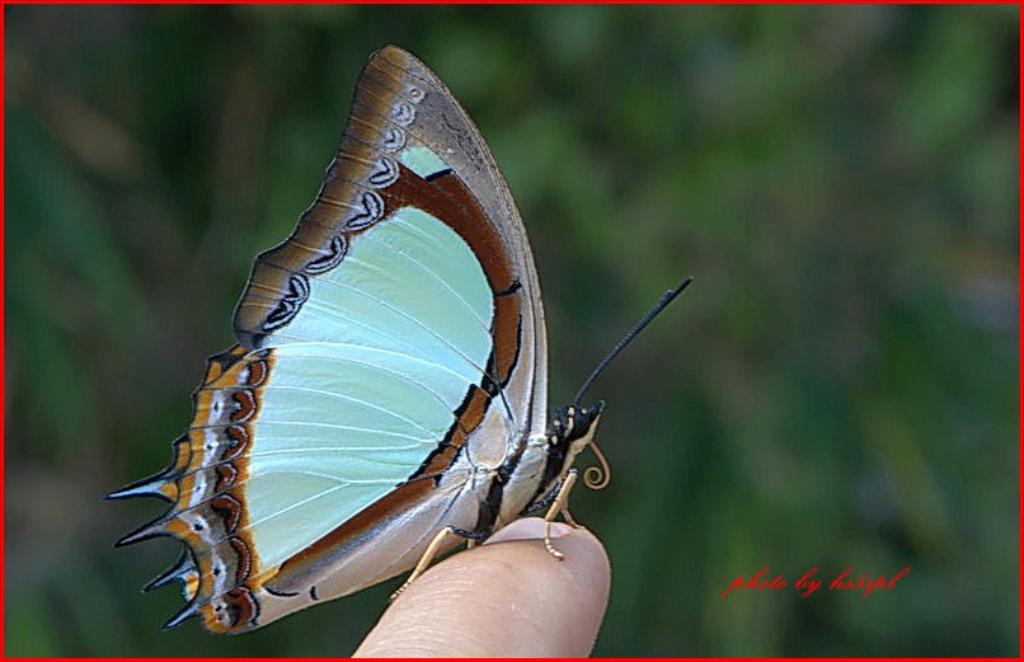What is the main subject of the image? There is a butterfly in the image. Where is the butterfly located in the image? The butterfly is on a finger. What else can be seen in the background of the image? There is text in the background of the image. How would you describe the appearance of the text? The text is blurred. How does the butterfly contribute to the digestion process in the image? The butterfly does not contribute to the digestion process in the image, as it is not involved in any digestive activity. 